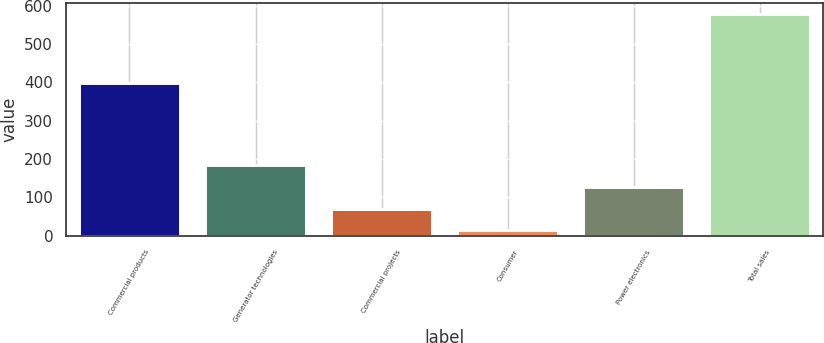Convert chart to OTSL. <chart><loc_0><loc_0><loc_500><loc_500><bar_chart><fcel>Commercial products<fcel>Generator technologies<fcel>Commercial projects<fcel>Consumer<fcel>Power electronics<fcel>Total sales<nl><fcel>399<fcel>183.5<fcel>70.5<fcel>14<fcel>127<fcel>579<nl></chart> 